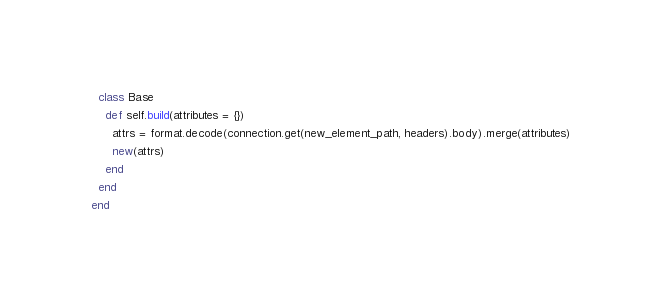Convert code to text. <code><loc_0><loc_0><loc_500><loc_500><_Ruby_>  class Base
    def self.build(attributes = {})
      attrs = format.decode(connection.get(new_element_path, headers).body).merge(attributes)
      new(attrs)
    end
  end
end
</code> 